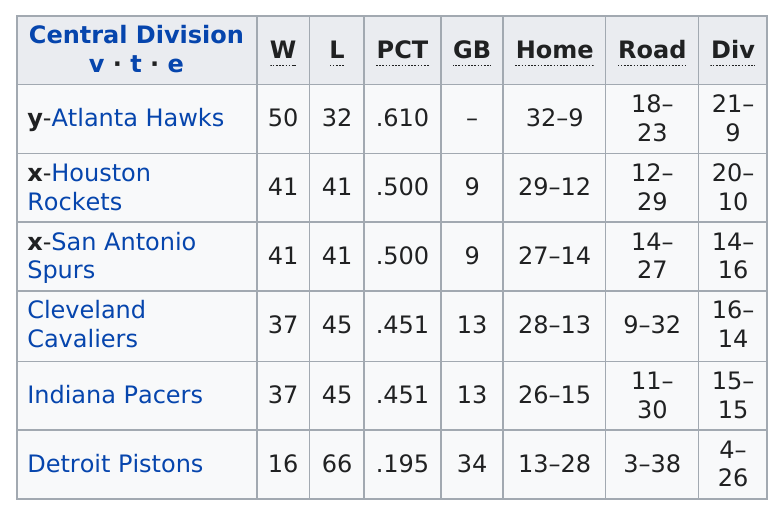Point out several critical features in this image. There are four teams that have the same number of losses (l). The Detroit Pistons have the most games behind (gb) in comparison to other teams. 